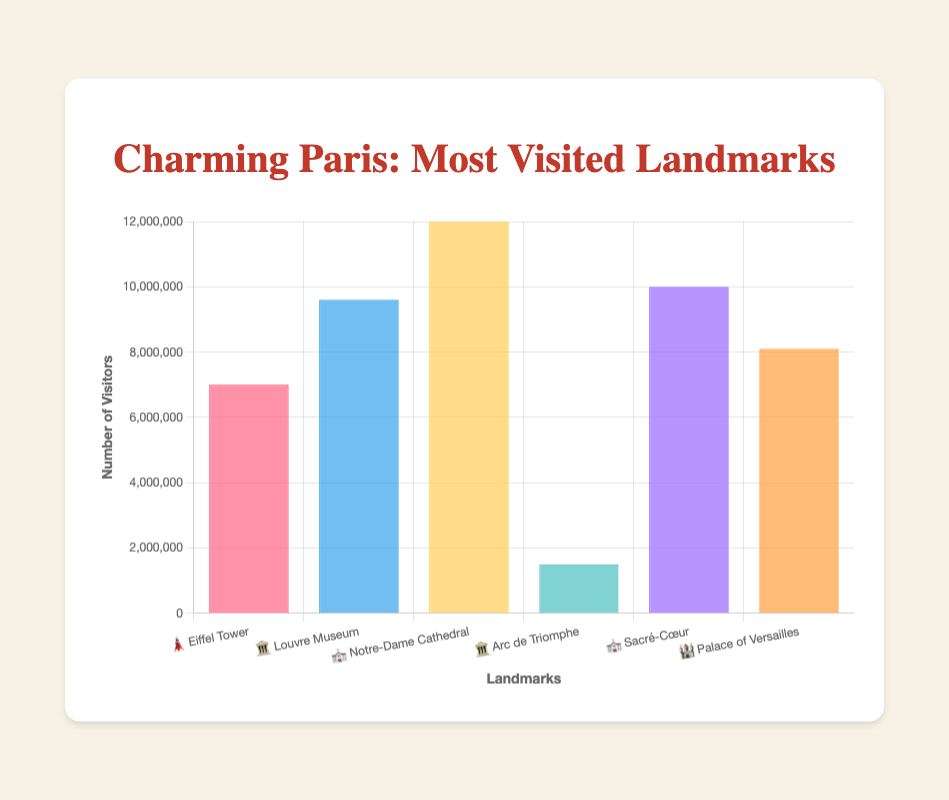What is the most visited landmark? 🗼, 🏛️, ⛪, 🏛️, ⛪, 🏰 The tallest bar in the chart represents the landmark with the highest number of visitors. Notre-Dame Cathedral has the tallest bar with 12,000,000 visitors.
Answer: Notre-Dame Cathedral (⛪) How many visitors does the Palace of Versailles have? 🏰 Find the bar labeled with the Palace of Versailles and check its height on the y-axis. The chart shows approximately 8,100,000 visitors for the Palace of Versailles.
Answer: 8,100,000 Which has more visitors: the Arc de Triomphe or the Eiffel Tower? 🏛️ vs 🗼 Compare the heights of the bars for the Arc de Triomphe and the Eiffel Tower. The Arc de Triomphe has 1,500,000 visitors, and the Eiffel Tower has 7,000,000 visitors, so the Eiffel Tower has more visitors.
Answer: Eiffel Tower (🗼) What is the combined number of visitors for the Louvre Museum and Sacré-Cœur? 🏛️+⛪ Add the number of visitors for the Louvre Museum and Sacré-Cœur. The Louvre Museum has 9,600,000 and Sacré-Cœur has 10,000,000 visitors: 9,600,000 + 10,000,000 = 19,600,000.
Answer: 19,600,000 Which landmark has the second highest number of visitors? 🗼, 🏛️, ⛪, 🏛️, ⛪, 🏰 Look for the second tallest bar in the chart. The second highest number of visitors is for Sacré-Cœur with 10,000,000 visitors, right after Notre-Dame Cathedral.
Answer: Sacré-Cœur (⛪) What is the average number of visitors across all landmarks? 🗼, 🏛️, ⛪, 🏛️, ⛪, 🏰 Sum the number of visitors for all landmarks and divide by the number of landmarks: (7,000,000 + 9,600,000 + 12,000,000 + 1,500,000 + 10,000,000 + 8,100,000) / 6 = 8,366,667.
Answer: 8,366,667 Rank the landmarks from most visited to least visited. 🗼, 🏛️, ⛪, 🏛️, ⛪, 🏰 Order them based on the heights of the bars. The ranking is: Notre-Dame Cathedral, Sacré-Cœur, Louvre Museum, Palace of Versailles, Eiffel Tower, Arc de Triomphe.
Answer: ⛪, ⛪, 🏛️, 🏰, 🗼, 🏛️ Which landmarks have over 8 million visitors? 🗼, 🏛️, ⛪, 🏛️, ⛪, 🏰 Identify bars that are above the 8 million mark on the y-axis. The landmarks are Eiffel Tower, Louvre Museum, Notre-Dame Cathedral, Sacré-Cœur, and Palace of Versailles.
Answer: 🗼, 🏛️, ⛪, ⛪, 🏰 